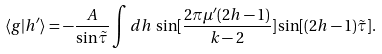<formula> <loc_0><loc_0><loc_500><loc_500>\langle g | h ^ { \prime } \rangle = - \frac { A } { \sin { \tilde { \tau } } } \int d h \, \sin [ \frac { 2 \pi \mu ^ { \prime } ( 2 h - 1 ) } { k - 2 } ] \sin [ ( 2 h - 1 ) { \tilde { \tau } } ] .</formula> 